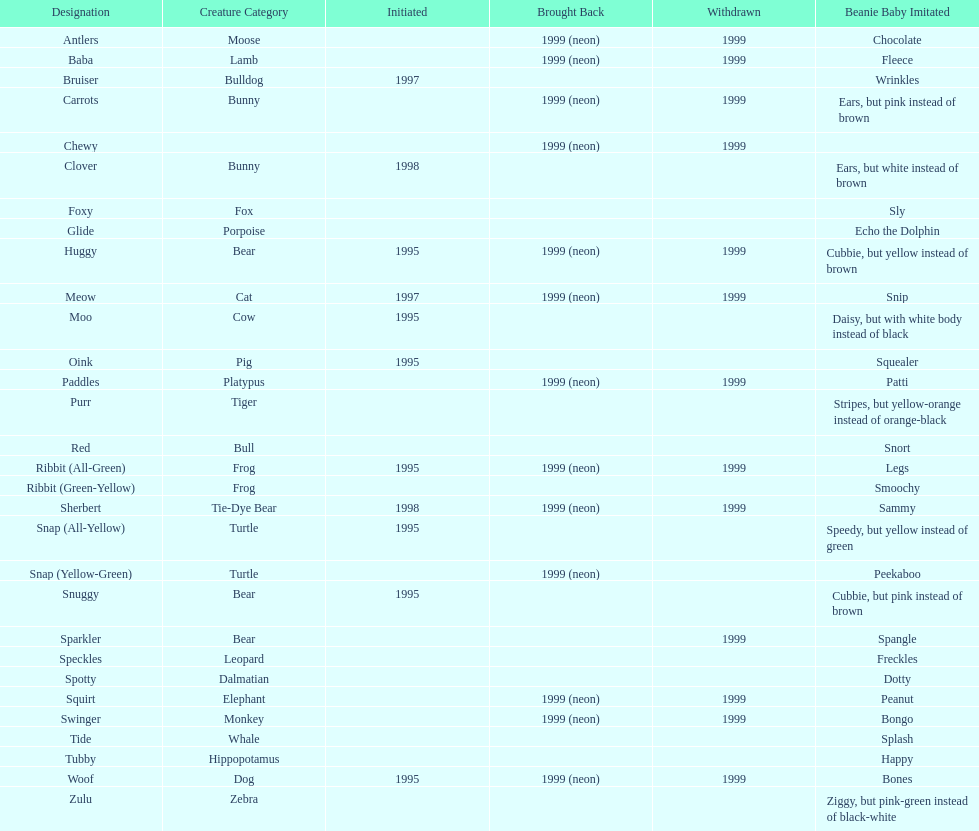What is the total number of pillow pals that were reintroduced as a neon variety? 13. 